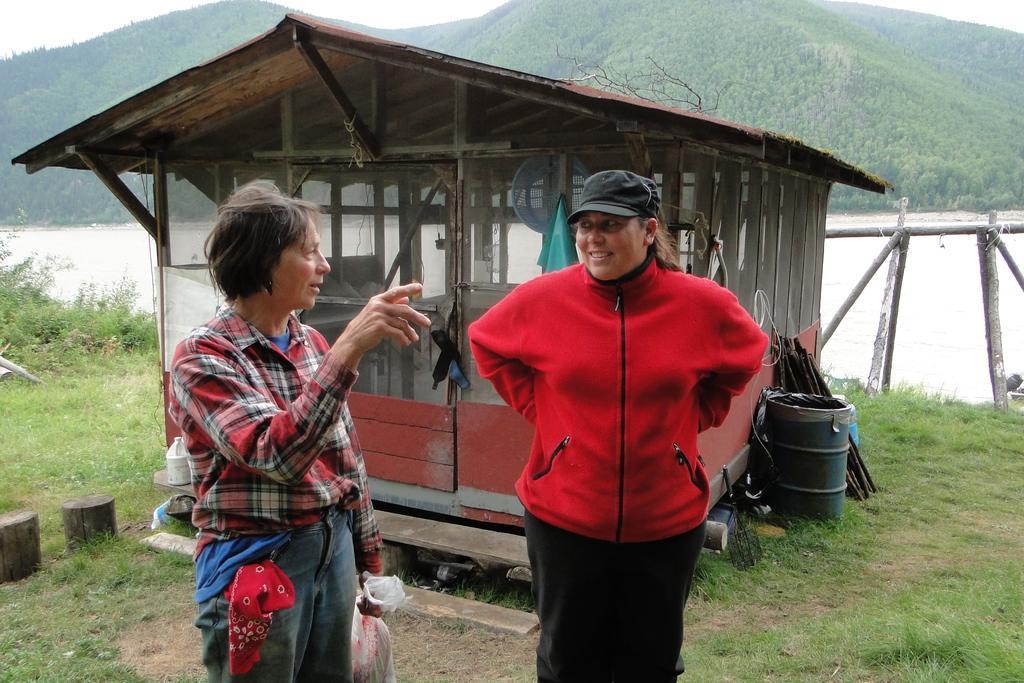Can you describe this image briefly? In the image we can see two people standing, wearing clothes and they are talking to each other. The right side person is wearing the cap and the left side person is holding a plastic cover in hand. Here we can see grass, house made up of glass and the mountains. We can even see water, fence and the sky. 